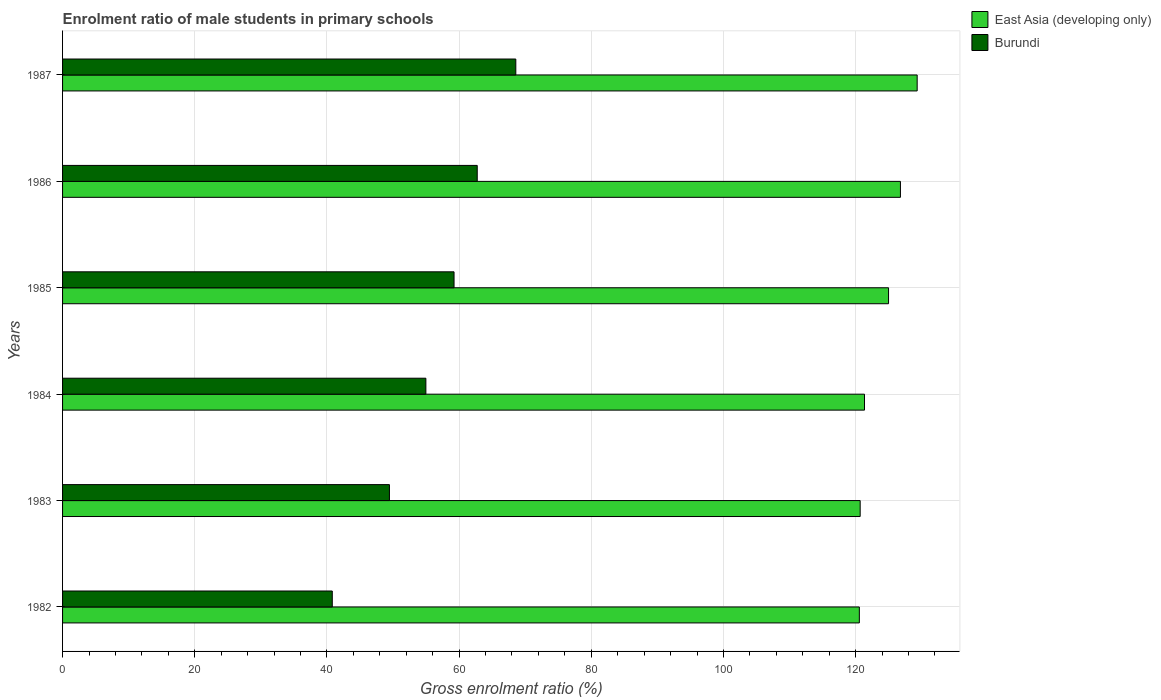How many different coloured bars are there?
Your answer should be compact. 2. How many groups of bars are there?
Your answer should be compact. 6. Are the number of bars on each tick of the Y-axis equal?
Offer a terse response. Yes. How many bars are there on the 4th tick from the top?
Provide a short and direct response. 2. In how many cases, is the number of bars for a given year not equal to the number of legend labels?
Your answer should be compact. 0. What is the enrolment ratio of male students in primary schools in Burundi in 1986?
Ensure brevity in your answer.  62.74. Across all years, what is the maximum enrolment ratio of male students in primary schools in Burundi?
Your response must be concise. 68.58. Across all years, what is the minimum enrolment ratio of male students in primary schools in Burundi?
Offer a terse response. 40.81. In which year was the enrolment ratio of male students in primary schools in East Asia (developing only) minimum?
Provide a succinct answer. 1982. What is the total enrolment ratio of male students in primary schools in Burundi in the graph?
Provide a succinct answer. 335.8. What is the difference between the enrolment ratio of male students in primary schools in East Asia (developing only) in 1986 and that in 1987?
Offer a terse response. -2.53. What is the difference between the enrolment ratio of male students in primary schools in Burundi in 1985 and the enrolment ratio of male students in primary schools in East Asia (developing only) in 1982?
Offer a very short reply. -61.32. What is the average enrolment ratio of male students in primary schools in East Asia (developing only) per year?
Give a very brief answer. 123.94. In the year 1987, what is the difference between the enrolment ratio of male students in primary schools in Burundi and enrolment ratio of male students in primary schools in East Asia (developing only)?
Ensure brevity in your answer.  -60.73. In how many years, is the enrolment ratio of male students in primary schools in East Asia (developing only) greater than 124 %?
Offer a terse response. 3. What is the ratio of the enrolment ratio of male students in primary schools in East Asia (developing only) in 1983 to that in 1984?
Provide a succinct answer. 0.99. Is the enrolment ratio of male students in primary schools in Burundi in 1982 less than that in 1986?
Make the answer very short. Yes. Is the difference between the enrolment ratio of male students in primary schools in Burundi in 1983 and 1987 greater than the difference between the enrolment ratio of male students in primary schools in East Asia (developing only) in 1983 and 1987?
Provide a succinct answer. No. What is the difference between the highest and the second highest enrolment ratio of male students in primary schools in Burundi?
Offer a terse response. 5.84. What is the difference between the highest and the lowest enrolment ratio of male students in primary schools in Burundi?
Keep it short and to the point. 27.77. Is the sum of the enrolment ratio of male students in primary schools in Burundi in 1982 and 1986 greater than the maximum enrolment ratio of male students in primary schools in East Asia (developing only) across all years?
Give a very brief answer. No. What does the 2nd bar from the top in 1987 represents?
Your answer should be compact. East Asia (developing only). What does the 1st bar from the bottom in 1983 represents?
Ensure brevity in your answer.  East Asia (developing only). Are all the bars in the graph horizontal?
Your answer should be compact. Yes. Does the graph contain any zero values?
Your answer should be very brief. No. Where does the legend appear in the graph?
Provide a short and direct response. Top right. What is the title of the graph?
Your answer should be compact. Enrolment ratio of male students in primary schools. What is the label or title of the X-axis?
Provide a succinct answer. Gross enrolment ratio (%). What is the label or title of the Y-axis?
Keep it short and to the point. Years. What is the Gross enrolment ratio (%) in East Asia (developing only) in 1982?
Make the answer very short. 120.56. What is the Gross enrolment ratio (%) of Burundi in 1982?
Make the answer very short. 40.81. What is the Gross enrolment ratio (%) in East Asia (developing only) in 1983?
Your answer should be very brief. 120.68. What is the Gross enrolment ratio (%) of Burundi in 1983?
Offer a terse response. 49.46. What is the Gross enrolment ratio (%) of East Asia (developing only) in 1984?
Make the answer very short. 121.34. What is the Gross enrolment ratio (%) of Burundi in 1984?
Your answer should be very brief. 54.97. What is the Gross enrolment ratio (%) in East Asia (developing only) in 1985?
Make the answer very short. 124.98. What is the Gross enrolment ratio (%) in Burundi in 1985?
Keep it short and to the point. 59.23. What is the Gross enrolment ratio (%) of East Asia (developing only) in 1986?
Give a very brief answer. 126.78. What is the Gross enrolment ratio (%) of Burundi in 1986?
Offer a terse response. 62.74. What is the Gross enrolment ratio (%) of East Asia (developing only) in 1987?
Ensure brevity in your answer.  129.31. What is the Gross enrolment ratio (%) in Burundi in 1987?
Give a very brief answer. 68.58. Across all years, what is the maximum Gross enrolment ratio (%) of East Asia (developing only)?
Your answer should be very brief. 129.31. Across all years, what is the maximum Gross enrolment ratio (%) of Burundi?
Make the answer very short. 68.58. Across all years, what is the minimum Gross enrolment ratio (%) of East Asia (developing only)?
Ensure brevity in your answer.  120.56. Across all years, what is the minimum Gross enrolment ratio (%) in Burundi?
Provide a short and direct response. 40.81. What is the total Gross enrolment ratio (%) in East Asia (developing only) in the graph?
Your answer should be compact. 743.64. What is the total Gross enrolment ratio (%) of Burundi in the graph?
Provide a short and direct response. 335.8. What is the difference between the Gross enrolment ratio (%) of East Asia (developing only) in 1982 and that in 1983?
Your response must be concise. -0.12. What is the difference between the Gross enrolment ratio (%) in Burundi in 1982 and that in 1983?
Offer a very short reply. -8.65. What is the difference between the Gross enrolment ratio (%) of East Asia (developing only) in 1982 and that in 1984?
Offer a terse response. -0.78. What is the difference between the Gross enrolment ratio (%) in Burundi in 1982 and that in 1984?
Provide a short and direct response. -14.16. What is the difference between the Gross enrolment ratio (%) of East Asia (developing only) in 1982 and that in 1985?
Give a very brief answer. -4.42. What is the difference between the Gross enrolment ratio (%) in Burundi in 1982 and that in 1985?
Ensure brevity in your answer.  -18.42. What is the difference between the Gross enrolment ratio (%) in East Asia (developing only) in 1982 and that in 1986?
Keep it short and to the point. -6.22. What is the difference between the Gross enrolment ratio (%) in Burundi in 1982 and that in 1986?
Offer a very short reply. -21.93. What is the difference between the Gross enrolment ratio (%) of East Asia (developing only) in 1982 and that in 1987?
Keep it short and to the point. -8.75. What is the difference between the Gross enrolment ratio (%) of Burundi in 1982 and that in 1987?
Provide a succinct answer. -27.77. What is the difference between the Gross enrolment ratio (%) in East Asia (developing only) in 1983 and that in 1984?
Provide a succinct answer. -0.65. What is the difference between the Gross enrolment ratio (%) in Burundi in 1983 and that in 1984?
Offer a very short reply. -5.51. What is the difference between the Gross enrolment ratio (%) in East Asia (developing only) in 1983 and that in 1985?
Keep it short and to the point. -4.29. What is the difference between the Gross enrolment ratio (%) of Burundi in 1983 and that in 1985?
Your response must be concise. -9.78. What is the difference between the Gross enrolment ratio (%) of East Asia (developing only) in 1983 and that in 1986?
Your answer should be compact. -6.09. What is the difference between the Gross enrolment ratio (%) of Burundi in 1983 and that in 1986?
Provide a succinct answer. -13.28. What is the difference between the Gross enrolment ratio (%) in East Asia (developing only) in 1983 and that in 1987?
Provide a short and direct response. -8.62. What is the difference between the Gross enrolment ratio (%) of Burundi in 1983 and that in 1987?
Your answer should be very brief. -19.12. What is the difference between the Gross enrolment ratio (%) of East Asia (developing only) in 1984 and that in 1985?
Offer a terse response. -3.64. What is the difference between the Gross enrolment ratio (%) of Burundi in 1984 and that in 1985?
Provide a succinct answer. -4.26. What is the difference between the Gross enrolment ratio (%) of East Asia (developing only) in 1984 and that in 1986?
Provide a succinct answer. -5.44. What is the difference between the Gross enrolment ratio (%) of Burundi in 1984 and that in 1986?
Offer a terse response. -7.77. What is the difference between the Gross enrolment ratio (%) in East Asia (developing only) in 1984 and that in 1987?
Make the answer very short. -7.97. What is the difference between the Gross enrolment ratio (%) of Burundi in 1984 and that in 1987?
Your answer should be compact. -13.61. What is the difference between the Gross enrolment ratio (%) in East Asia (developing only) in 1985 and that in 1986?
Your answer should be very brief. -1.8. What is the difference between the Gross enrolment ratio (%) in Burundi in 1985 and that in 1986?
Your answer should be very brief. -3.51. What is the difference between the Gross enrolment ratio (%) in East Asia (developing only) in 1985 and that in 1987?
Give a very brief answer. -4.33. What is the difference between the Gross enrolment ratio (%) of Burundi in 1985 and that in 1987?
Provide a short and direct response. -9.35. What is the difference between the Gross enrolment ratio (%) of East Asia (developing only) in 1986 and that in 1987?
Offer a terse response. -2.53. What is the difference between the Gross enrolment ratio (%) in Burundi in 1986 and that in 1987?
Your answer should be compact. -5.84. What is the difference between the Gross enrolment ratio (%) in East Asia (developing only) in 1982 and the Gross enrolment ratio (%) in Burundi in 1983?
Your answer should be very brief. 71.1. What is the difference between the Gross enrolment ratio (%) of East Asia (developing only) in 1982 and the Gross enrolment ratio (%) of Burundi in 1984?
Your answer should be compact. 65.59. What is the difference between the Gross enrolment ratio (%) of East Asia (developing only) in 1982 and the Gross enrolment ratio (%) of Burundi in 1985?
Provide a short and direct response. 61.32. What is the difference between the Gross enrolment ratio (%) of East Asia (developing only) in 1982 and the Gross enrolment ratio (%) of Burundi in 1986?
Offer a very short reply. 57.82. What is the difference between the Gross enrolment ratio (%) in East Asia (developing only) in 1982 and the Gross enrolment ratio (%) in Burundi in 1987?
Provide a succinct answer. 51.98. What is the difference between the Gross enrolment ratio (%) in East Asia (developing only) in 1983 and the Gross enrolment ratio (%) in Burundi in 1984?
Provide a succinct answer. 65.71. What is the difference between the Gross enrolment ratio (%) of East Asia (developing only) in 1983 and the Gross enrolment ratio (%) of Burundi in 1985?
Your answer should be very brief. 61.45. What is the difference between the Gross enrolment ratio (%) in East Asia (developing only) in 1983 and the Gross enrolment ratio (%) in Burundi in 1986?
Give a very brief answer. 57.94. What is the difference between the Gross enrolment ratio (%) of East Asia (developing only) in 1983 and the Gross enrolment ratio (%) of Burundi in 1987?
Keep it short and to the point. 52.1. What is the difference between the Gross enrolment ratio (%) in East Asia (developing only) in 1984 and the Gross enrolment ratio (%) in Burundi in 1985?
Provide a succinct answer. 62.1. What is the difference between the Gross enrolment ratio (%) in East Asia (developing only) in 1984 and the Gross enrolment ratio (%) in Burundi in 1986?
Ensure brevity in your answer.  58.59. What is the difference between the Gross enrolment ratio (%) of East Asia (developing only) in 1984 and the Gross enrolment ratio (%) of Burundi in 1987?
Your response must be concise. 52.76. What is the difference between the Gross enrolment ratio (%) in East Asia (developing only) in 1985 and the Gross enrolment ratio (%) in Burundi in 1986?
Offer a terse response. 62.23. What is the difference between the Gross enrolment ratio (%) of East Asia (developing only) in 1985 and the Gross enrolment ratio (%) of Burundi in 1987?
Offer a terse response. 56.4. What is the difference between the Gross enrolment ratio (%) in East Asia (developing only) in 1986 and the Gross enrolment ratio (%) in Burundi in 1987?
Offer a terse response. 58.2. What is the average Gross enrolment ratio (%) of East Asia (developing only) per year?
Keep it short and to the point. 123.94. What is the average Gross enrolment ratio (%) of Burundi per year?
Provide a short and direct response. 55.97. In the year 1982, what is the difference between the Gross enrolment ratio (%) of East Asia (developing only) and Gross enrolment ratio (%) of Burundi?
Keep it short and to the point. 79.75. In the year 1983, what is the difference between the Gross enrolment ratio (%) in East Asia (developing only) and Gross enrolment ratio (%) in Burundi?
Ensure brevity in your answer.  71.22. In the year 1984, what is the difference between the Gross enrolment ratio (%) in East Asia (developing only) and Gross enrolment ratio (%) in Burundi?
Keep it short and to the point. 66.37. In the year 1985, what is the difference between the Gross enrolment ratio (%) in East Asia (developing only) and Gross enrolment ratio (%) in Burundi?
Offer a very short reply. 65.74. In the year 1986, what is the difference between the Gross enrolment ratio (%) of East Asia (developing only) and Gross enrolment ratio (%) of Burundi?
Offer a terse response. 64.03. In the year 1987, what is the difference between the Gross enrolment ratio (%) in East Asia (developing only) and Gross enrolment ratio (%) in Burundi?
Ensure brevity in your answer.  60.73. What is the ratio of the Gross enrolment ratio (%) in Burundi in 1982 to that in 1983?
Your answer should be very brief. 0.83. What is the ratio of the Gross enrolment ratio (%) in East Asia (developing only) in 1982 to that in 1984?
Your response must be concise. 0.99. What is the ratio of the Gross enrolment ratio (%) in Burundi in 1982 to that in 1984?
Ensure brevity in your answer.  0.74. What is the ratio of the Gross enrolment ratio (%) of East Asia (developing only) in 1982 to that in 1985?
Offer a very short reply. 0.96. What is the ratio of the Gross enrolment ratio (%) in Burundi in 1982 to that in 1985?
Keep it short and to the point. 0.69. What is the ratio of the Gross enrolment ratio (%) in East Asia (developing only) in 1982 to that in 1986?
Make the answer very short. 0.95. What is the ratio of the Gross enrolment ratio (%) of Burundi in 1982 to that in 1986?
Offer a very short reply. 0.65. What is the ratio of the Gross enrolment ratio (%) of East Asia (developing only) in 1982 to that in 1987?
Provide a short and direct response. 0.93. What is the ratio of the Gross enrolment ratio (%) of Burundi in 1982 to that in 1987?
Keep it short and to the point. 0.6. What is the ratio of the Gross enrolment ratio (%) in Burundi in 1983 to that in 1984?
Provide a succinct answer. 0.9. What is the ratio of the Gross enrolment ratio (%) of East Asia (developing only) in 1983 to that in 1985?
Provide a short and direct response. 0.97. What is the ratio of the Gross enrolment ratio (%) in Burundi in 1983 to that in 1985?
Give a very brief answer. 0.83. What is the ratio of the Gross enrolment ratio (%) in East Asia (developing only) in 1983 to that in 1986?
Your answer should be compact. 0.95. What is the ratio of the Gross enrolment ratio (%) in Burundi in 1983 to that in 1986?
Provide a short and direct response. 0.79. What is the ratio of the Gross enrolment ratio (%) in East Asia (developing only) in 1983 to that in 1987?
Give a very brief answer. 0.93. What is the ratio of the Gross enrolment ratio (%) in Burundi in 1983 to that in 1987?
Offer a terse response. 0.72. What is the ratio of the Gross enrolment ratio (%) of East Asia (developing only) in 1984 to that in 1985?
Provide a short and direct response. 0.97. What is the ratio of the Gross enrolment ratio (%) of Burundi in 1984 to that in 1985?
Your response must be concise. 0.93. What is the ratio of the Gross enrolment ratio (%) in East Asia (developing only) in 1984 to that in 1986?
Keep it short and to the point. 0.96. What is the ratio of the Gross enrolment ratio (%) of Burundi in 1984 to that in 1986?
Keep it short and to the point. 0.88. What is the ratio of the Gross enrolment ratio (%) in East Asia (developing only) in 1984 to that in 1987?
Your answer should be compact. 0.94. What is the ratio of the Gross enrolment ratio (%) of Burundi in 1984 to that in 1987?
Your answer should be compact. 0.8. What is the ratio of the Gross enrolment ratio (%) of East Asia (developing only) in 1985 to that in 1986?
Provide a succinct answer. 0.99. What is the ratio of the Gross enrolment ratio (%) in Burundi in 1985 to that in 1986?
Offer a very short reply. 0.94. What is the ratio of the Gross enrolment ratio (%) of East Asia (developing only) in 1985 to that in 1987?
Make the answer very short. 0.97. What is the ratio of the Gross enrolment ratio (%) of Burundi in 1985 to that in 1987?
Offer a very short reply. 0.86. What is the ratio of the Gross enrolment ratio (%) of East Asia (developing only) in 1986 to that in 1987?
Your answer should be compact. 0.98. What is the ratio of the Gross enrolment ratio (%) of Burundi in 1986 to that in 1987?
Your answer should be very brief. 0.91. What is the difference between the highest and the second highest Gross enrolment ratio (%) of East Asia (developing only)?
Your response must be concise. 2.53. What is the difference between the highest and the second highest Gross enrolment ratio (%) in Burundi?
Ensure brevity in your answer.  5.84. What is the difference between the highest and the lowest Gross enrolment ratio (%) of East Asia (developing only)?
Your response must be concise. 8.75. What is the difference between the highest and the lowest Gross enrolment ratio (%) of Burundi?
Make the answer very short. 27.77. 